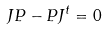<formula> <loc_0><loc_0><loc_500><loc_500>J P - P J ^ { t } = 0</formula> 